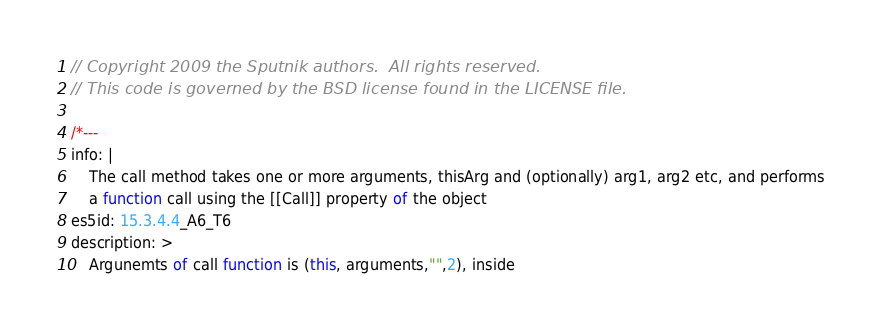<code> <loc_0><loc_0><loc_500><loc_500><_JavaScript_>// Copyright 2009 the Sputnik authors.  All rights reserved.
// This code is governed by the BSD license found in the LICENSE file.

/*---
info: |
    The call method takes one or more arguments, thisArg and (optionally) arg1, arg2 etc, and performs
    a function call using the [[Call]] property of the object
es5id: 15.3.4.4_A6_T6
description: >
    Argunemts of call function is (this, arguments,"",2), inside</code> 